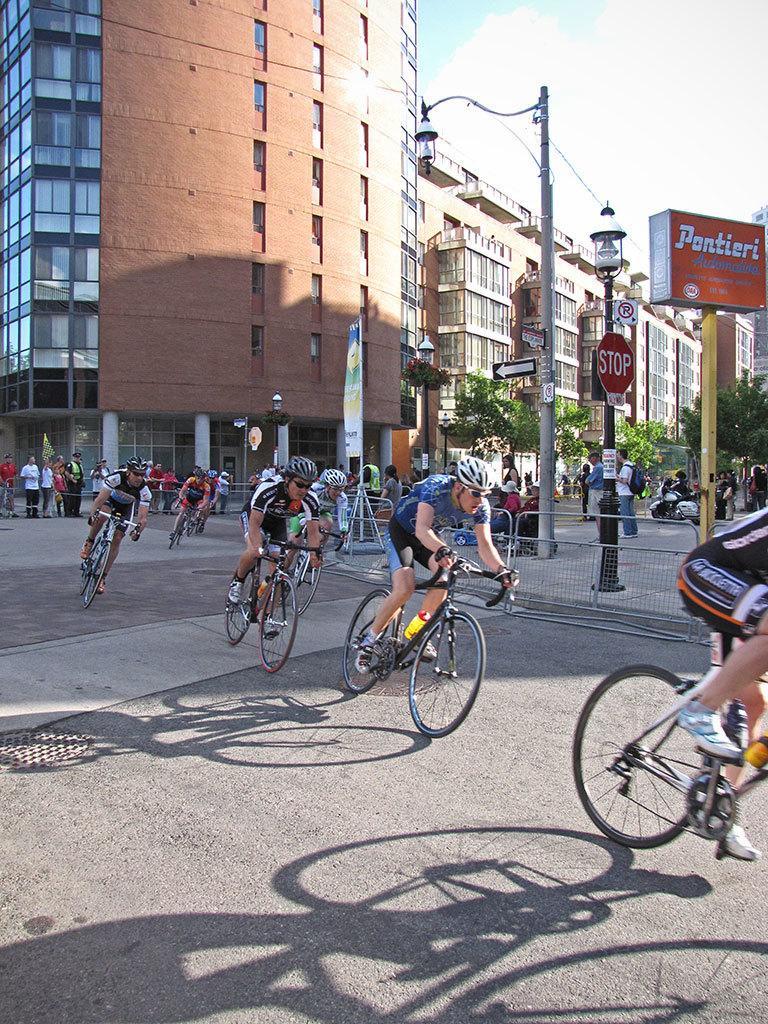How would you summarize this image in a sentence or two? In this image I can see the group of people riding their bicycles. These people are wearing the different color jerseys and also the helmets. To the side I can see the light pole and the boards to the pole. In the back I can see few people standing in-front of the building. There is a sky and clouds can be seen in the back. 